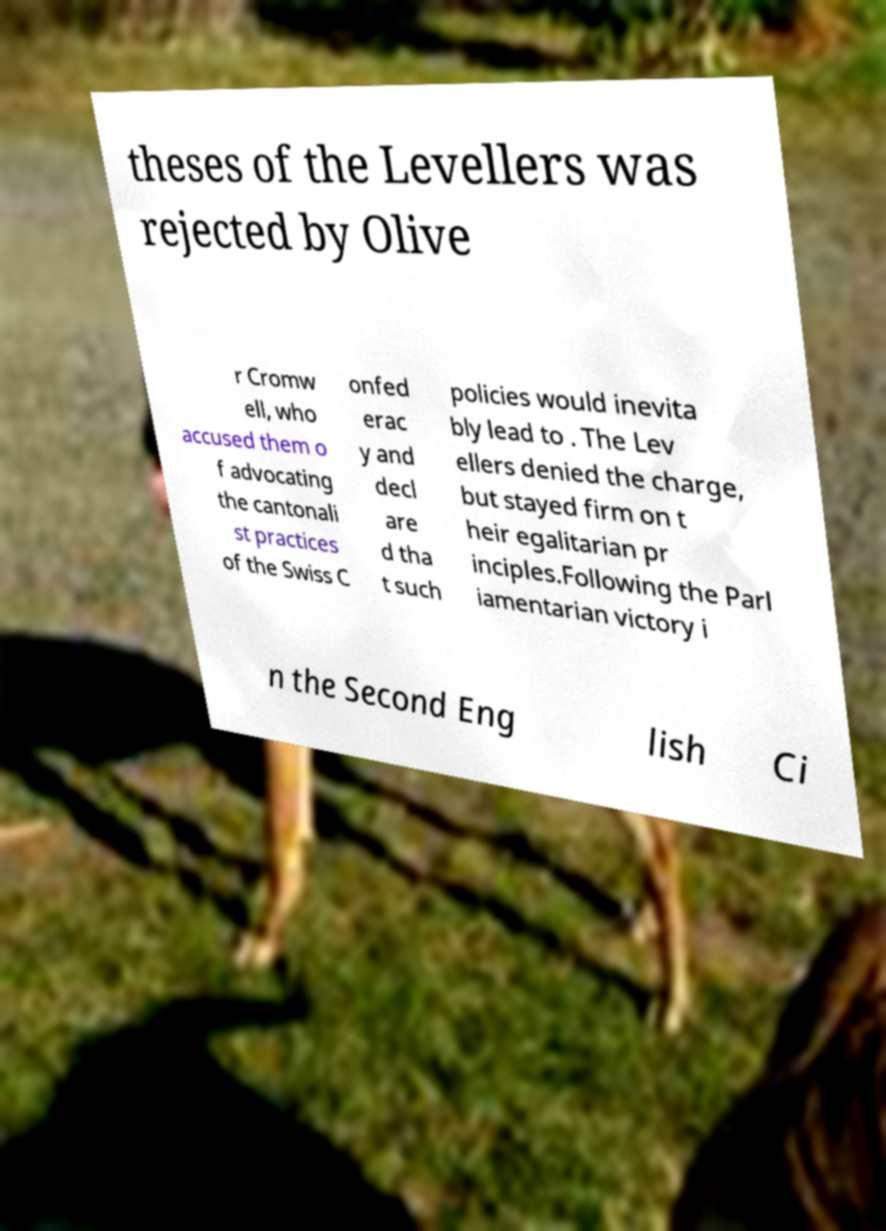There's text embedded in this image that I need extracted. Can you transcribe it verbatim? theses of the Levellers was rejected by Olive r Cromw ell, who accused them o f advocating the cantonali st practices of the Swiss C onfed erac y and decl are d tha t such policies would inevita bly lead to . The Lev ellers denied the charge, but stayed firm on t heir egalitarian pr inciples.Following the Parl iamentarian victory i n the Second Eng lish Ci 